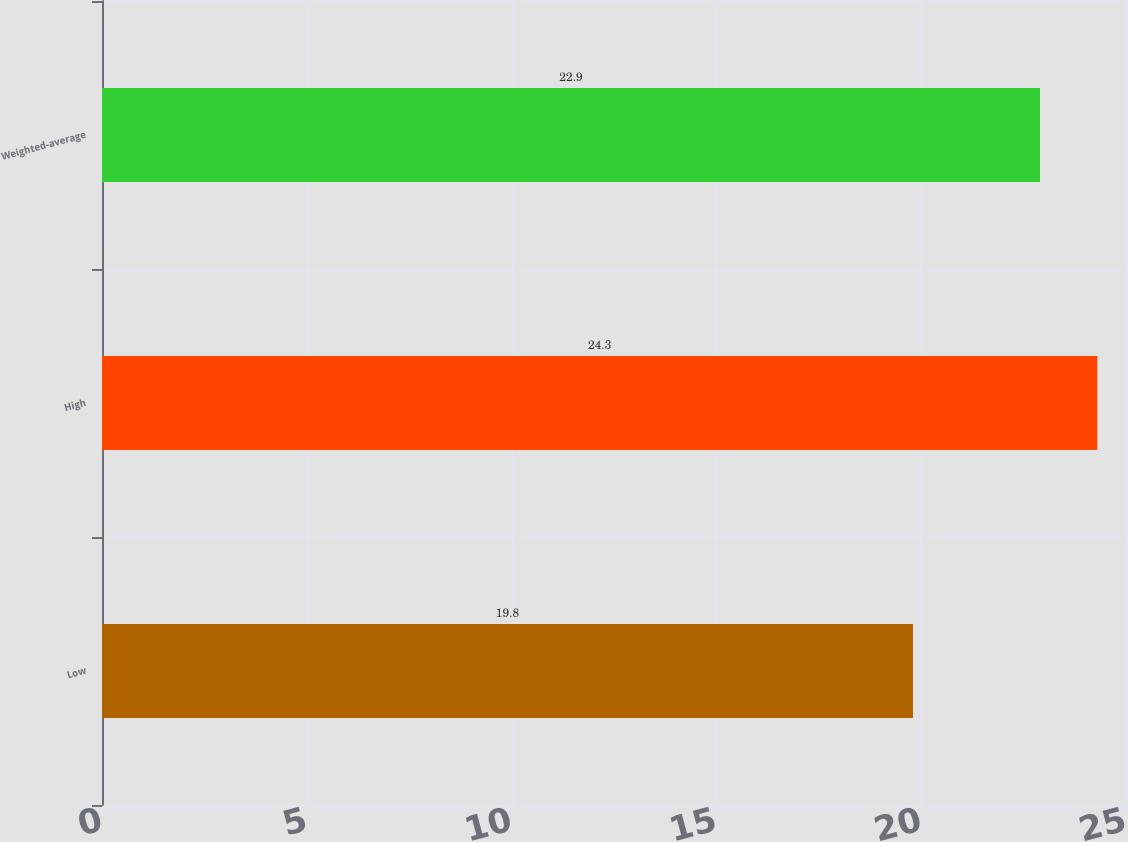Convert chart. <chart><loc_0><loc_0><loc_500><loc_500><bar_chart><fcel>Low<fcel>High<fcel>Weighted-average<nl><fcel>19.8<fcel>24.3<fcel>22.9<nl></chart> 